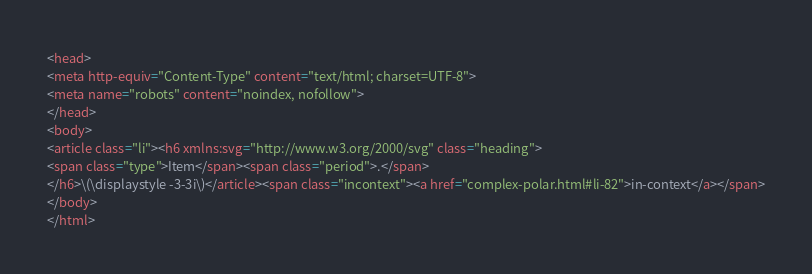Convert code to text. <code><loc_0><loc_0><loc_500><loc_500><_HTML_><head>
<meta http-equiv="Content-Type" content="text/html; charset=UTF-8">
<meta name="robots" content="noindex, nofollow">
</head>
<body>
<article class="li"><h6 xmlns:svg="http://www.w3.org/2000/svg" class="heading">
<span class="type">Item</span><span class="period">.</span>
</h6>\(\displaystyle -3-3i\)</article><span class="incontext"><a href="complex-polar.html#li-82">in-context</a></span>
</body>
</html>
</code> 